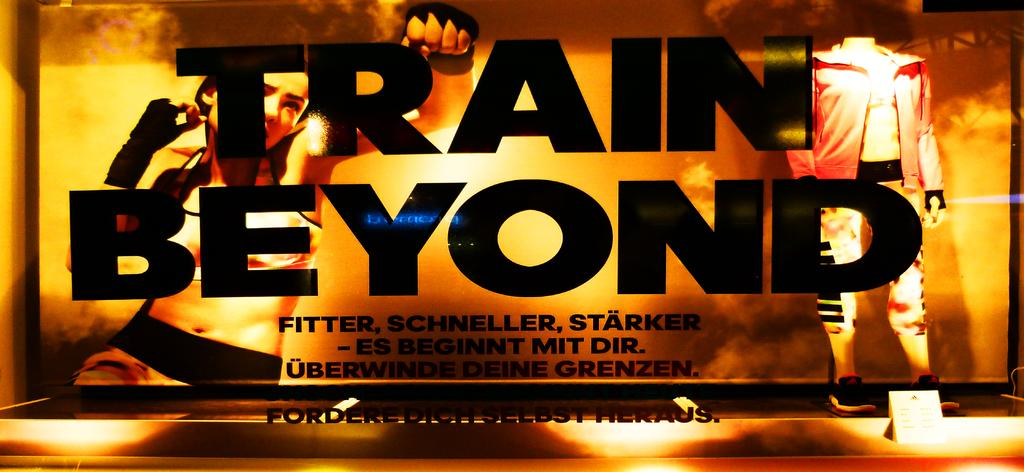<image>
Describe the image concisely. The sign has large letters encouraging  people to "train beyond". 